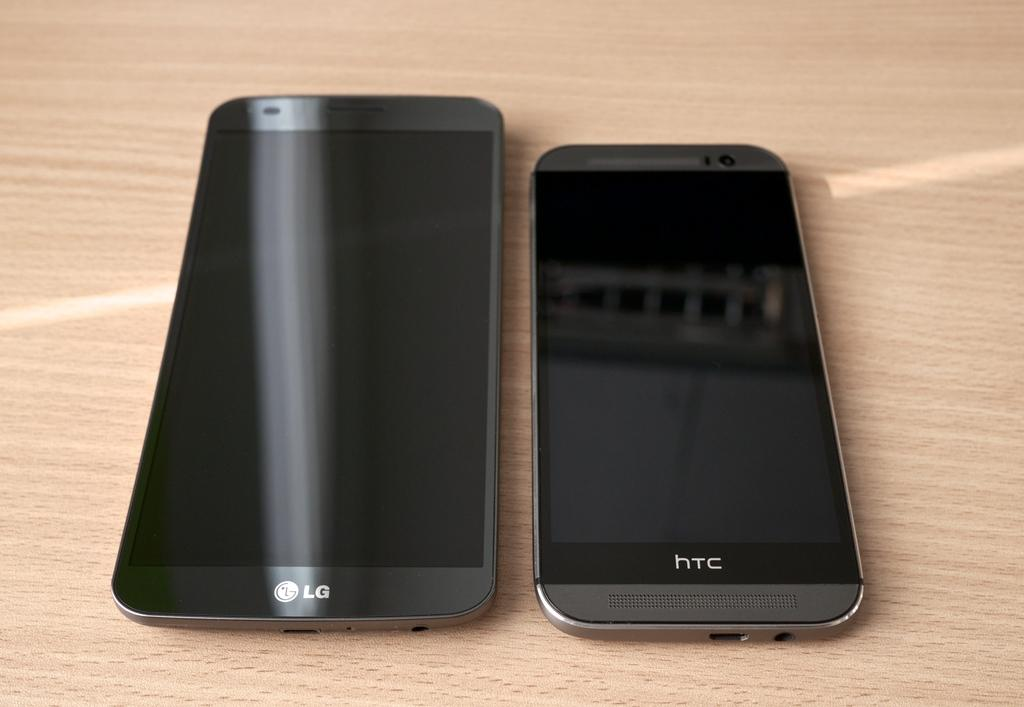<image>
Describe the image concisely. A black LG smart phone next to a black htc smart phone. 